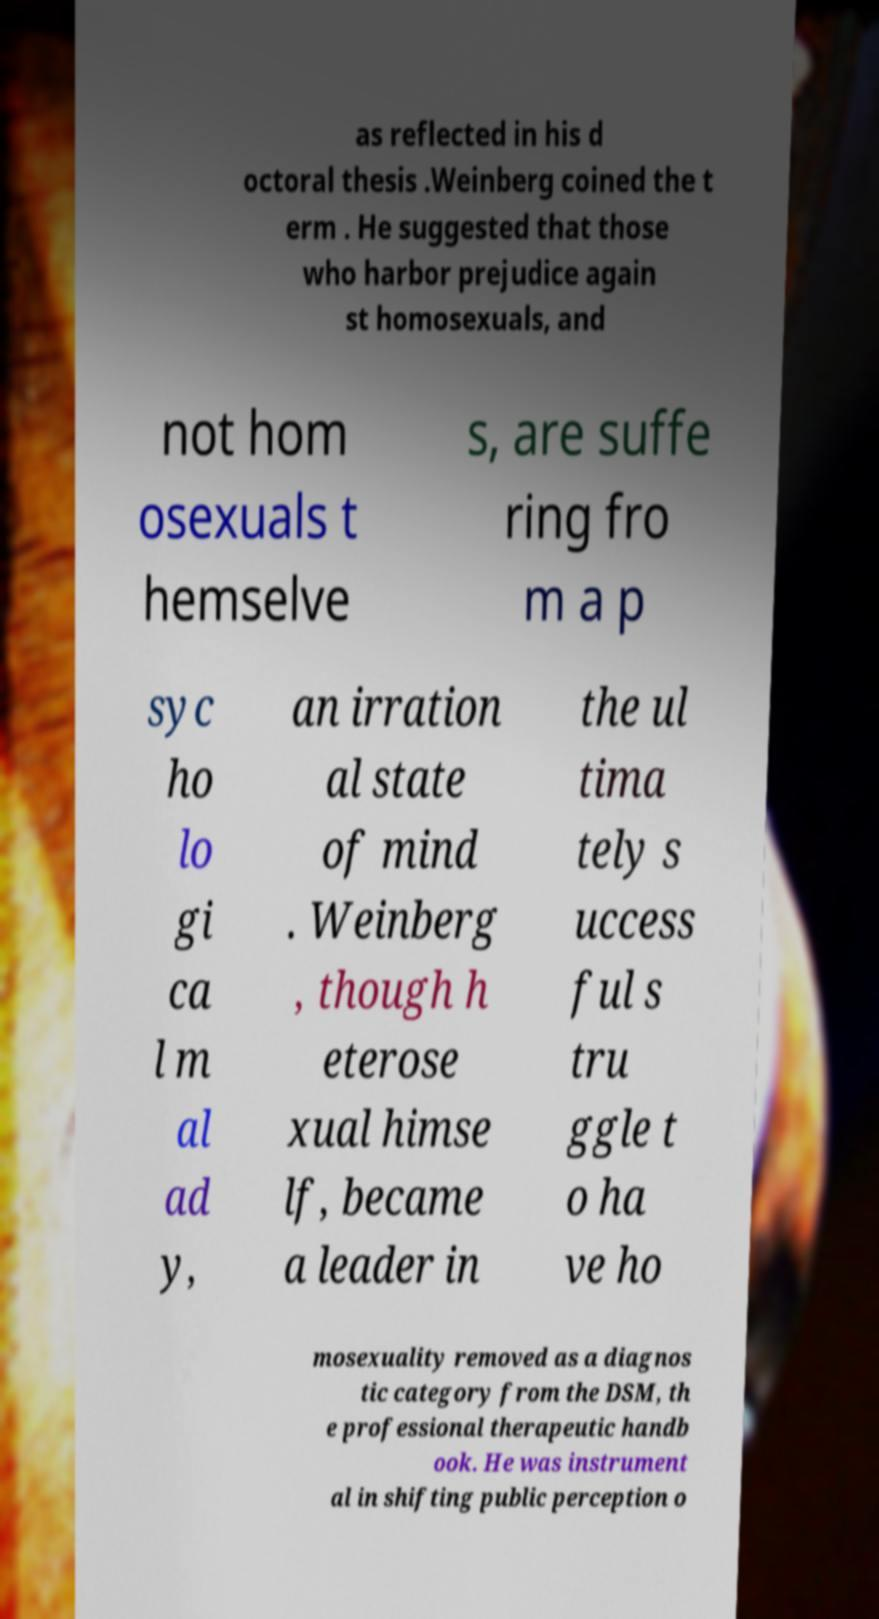Could you assist in decoding the text presented in this image and type it out clearly? as reflected in his d octoral thesis .Weinberg coined the t erm . He suggested that those who harbor prejudice again st homosexuals, and not hom osexuals t hemselve s, are suffe ring fro m a p syc ho lo gi ca l m al ad y, an irration al state of mind . Weinberg , though h eterose xual himse lf, became a leader in the ul tima tely s uccess ful s tru ggle t o ha ve ho mosexuality removed as a diagnos tic category from the DSM, th e professional therapeutic handb ook. He was instrument al in shifting public perception o 